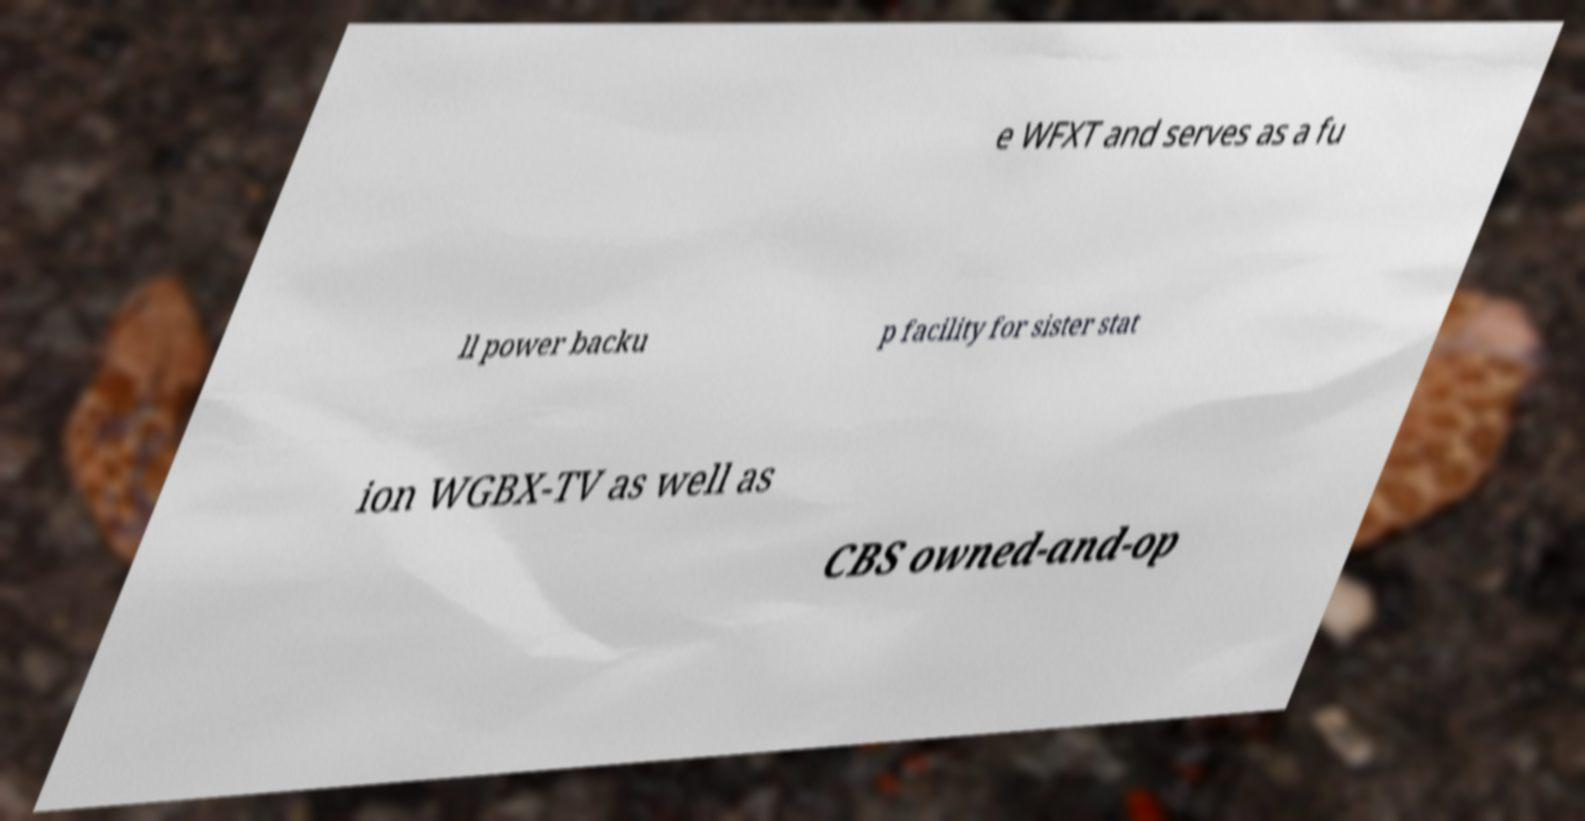Please read and relay the text visible in this image. What does it say? e WFXT and serves as a fu ll power backu p facility for sister stat ion WGBX-TV as well as CBS owned-and-op 